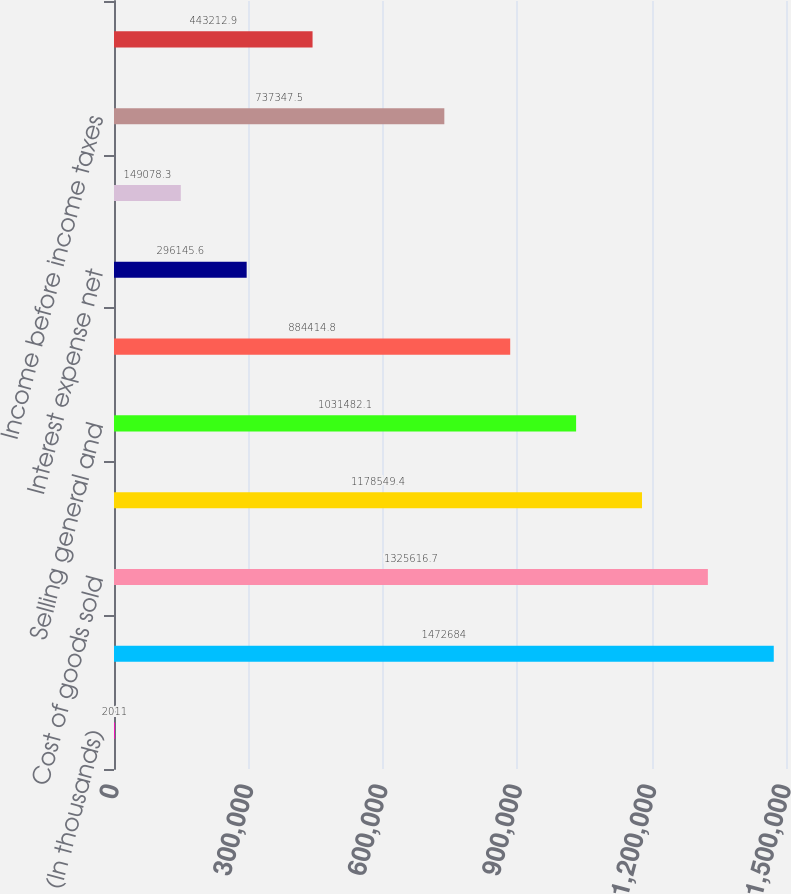Convert chart. <chart><loc_0><loc_0><loc_500><loc_500><bar_chart><fcel>(In thousands)<fcel>Net revenues<fcel>Cost of goods sold<fcel>Gross profit<fcel>Selling general and<fcel>Income from operations<fcel>Interest expense net<fcel>Other expense net<fcel>Income before income taxes<fcel>Provision for income taxes<nl><fcel>2011<fcel>1.47268e+06<fcel>1.32562e+06<fcel>1.17855e+06<fcel>1.03148e+06<fcel>884415<fcel>296146<fcel>149078<fcel>737348<fcel>443213<nl></chart> 